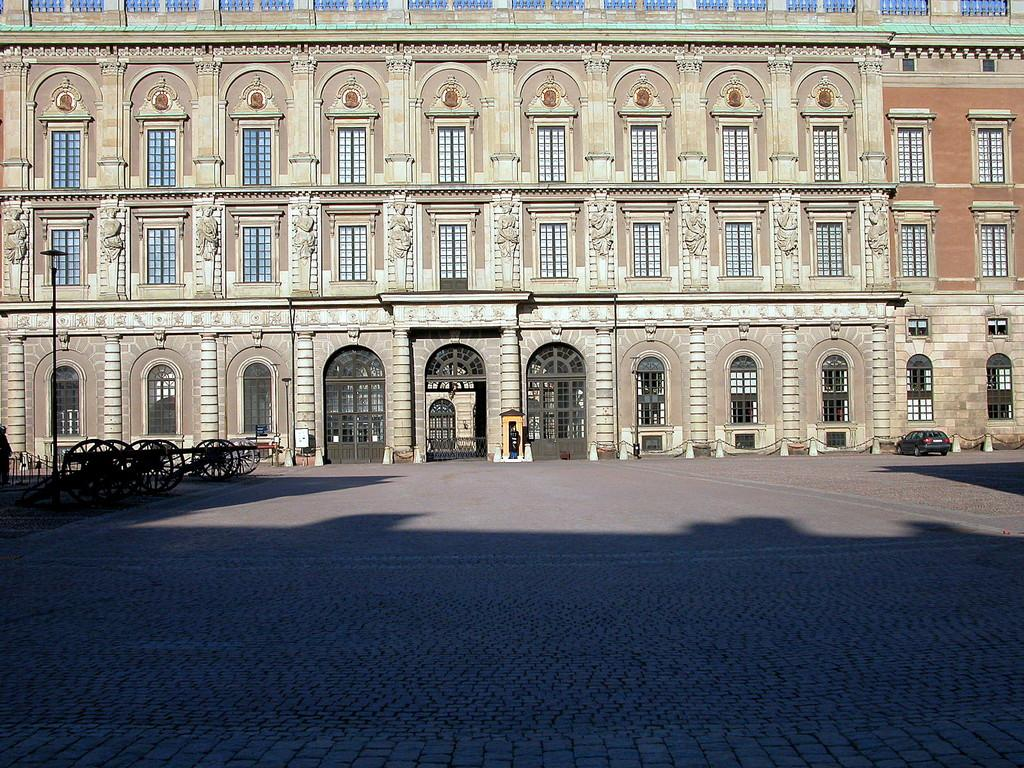What is visible at the base of the image? The ground is visible in the image. What type of vehicle can be seen in the image? There is a car in the image. What are the small, wheeled objects in the image? There are carts in the image. What type of structure is present in the image? There is a building with windows in the image. Can you describe the unspecified objects in the image? Unfortunately, the provided facts do not specify the nature of these objects. How many slaves are visible in the image? There are no slaves present in the image. What type of toys can be seen in the image? There are no toys present in the image. 